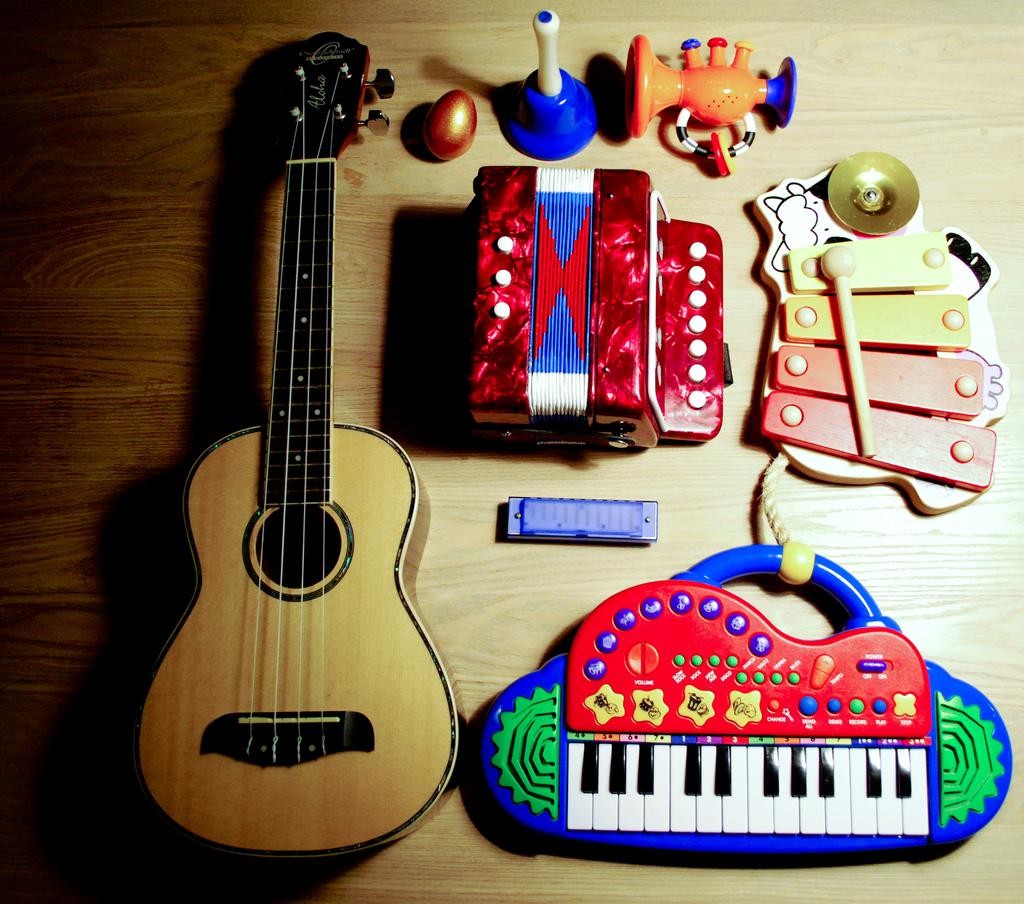What type of musical instruments can be seen in the image? There is a guitar, a xylophone, harmonicas, and a musical piano in the image. What other items are present on the table in the image? There is a toy and a plastic egg in the image. Can you describe the horn in the image? Yes, there is a horn in the image. Where are all these items located in the image? All these items are on a table in the image. How many tomatoes are on the table in the image? There are no tomatoes present in the image. What type of trouble can be seen in the image? There is no trouble depicted in the image; it features various musical instruments and other items on a table. 